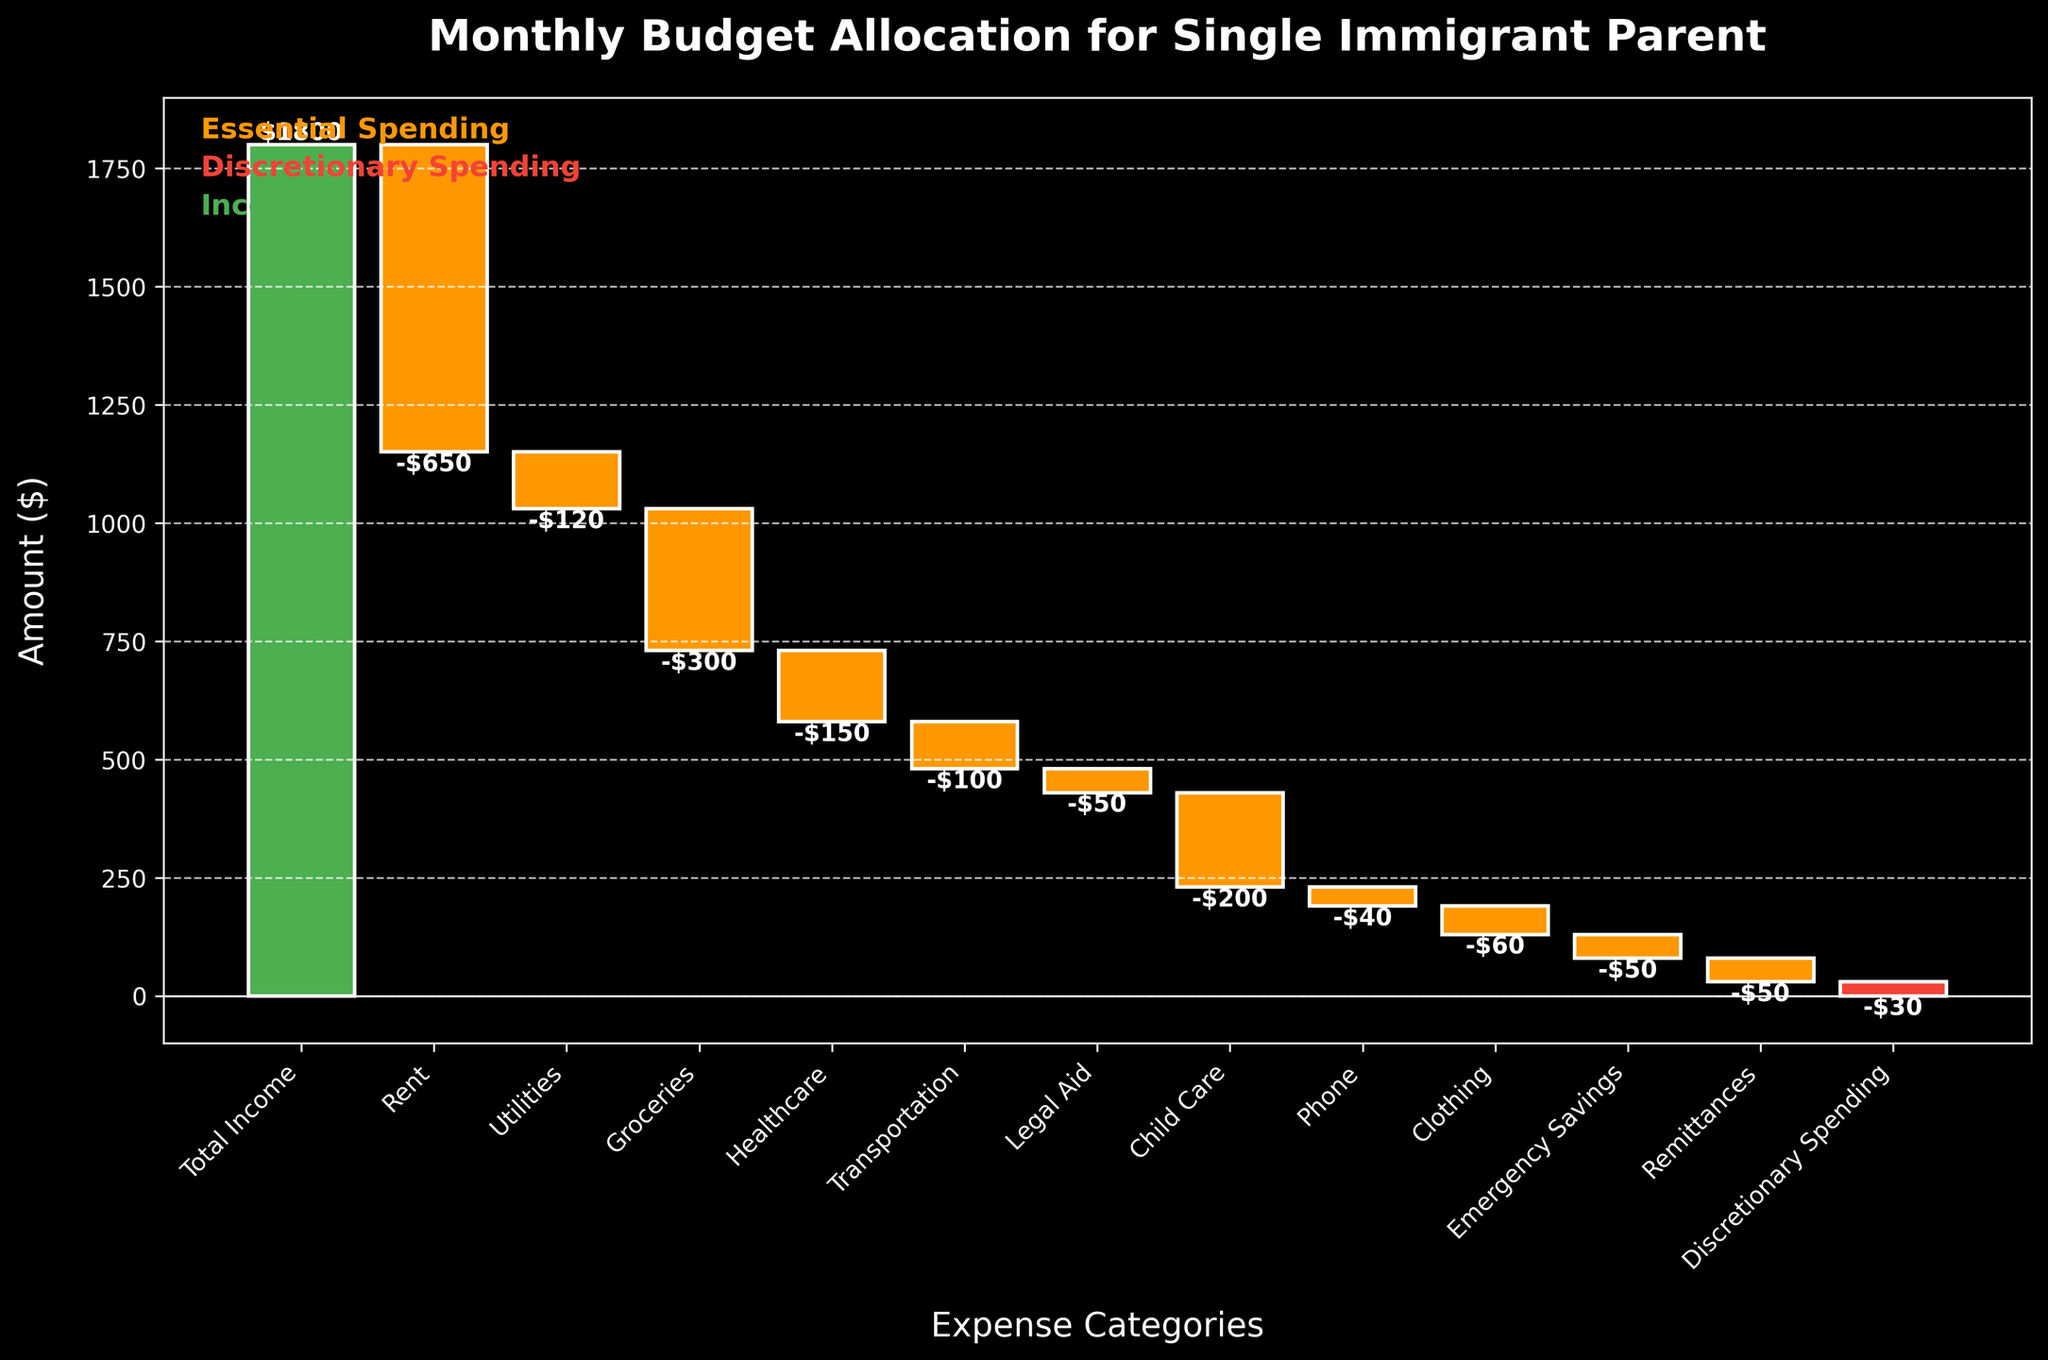How much is spent on Rent monthly? The Rent category bar is shown on the waterfall chart as -$650.
Answer: $650 What is the total income for the single immigrant parent? The total income category is the first bar on the chart labeled as $1800.
Answer: $1800 Which expense category contributes the most to essential spending? The bar for Rent appears the largest among the essential spending categories, indicating an amount of $650.
Answer: Rent What is the final balance after accounting for all expenses? The final balance is indicated by the last bar on the chart, which touches the x-axis at around $0.
Answer: $0 How much is allocated to emergency savings? The Emergency Savings category bar shows an amount of -$50.
Answer: $50 Between Healthcare and Groceries, which category has a higher monthly expense? By comparing the bars, Groceries is taller (or lower in value) compared to Healthcare, implying Groceries cost $300 and Healthcare costs $150.
Answer: Groceries What percentage of the total income is spent on Transportation? The total income is $1800, and Transportation is $100. To find the percentage, calculate \($100 / $1800 * 100\)
Answer: 5.56% What is the combined expense of Legal Aid and Child Care? Legal Aid amounts to $50 and Child Care amounts to $200. Adding these together results in $50 + $200 = $250.
Answer: $250 Is there a category with a positive contribution other than Total Income? All bars other than the total income (first bar) show reductions from the cumulative total, thus no other category contributes positively.
Answer: No How much is spent on Discretionary Spending monthly? The Discretionary Spending category bar shows a value of -$30 on the chart.
Answer: $30 